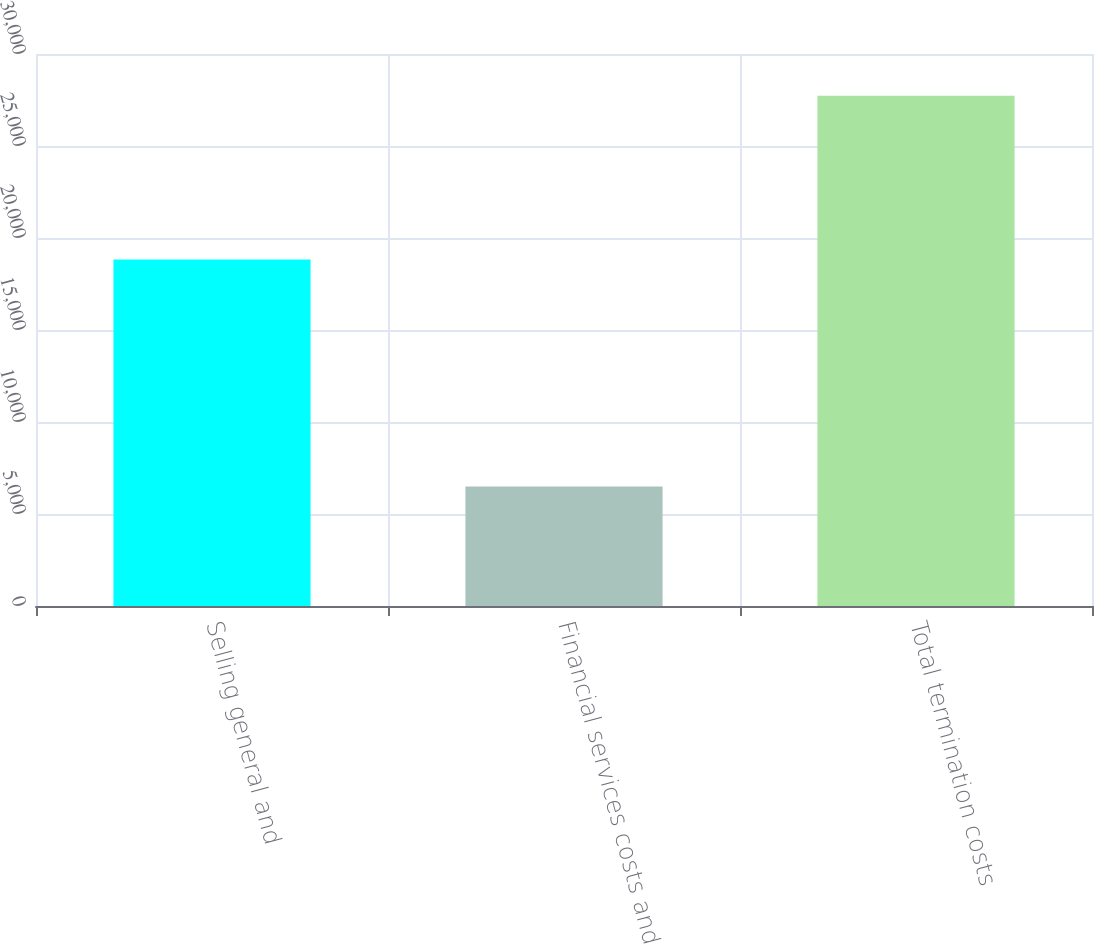<chart> <loc_0><loc_0><loc_500><loc_500><bar_chart><fcel>Selling general and<fcel>Financial services costs and<fcel>Total termination costs<nl><fcel>18830<fcel>6498<fcel>27729<nl></chart> 